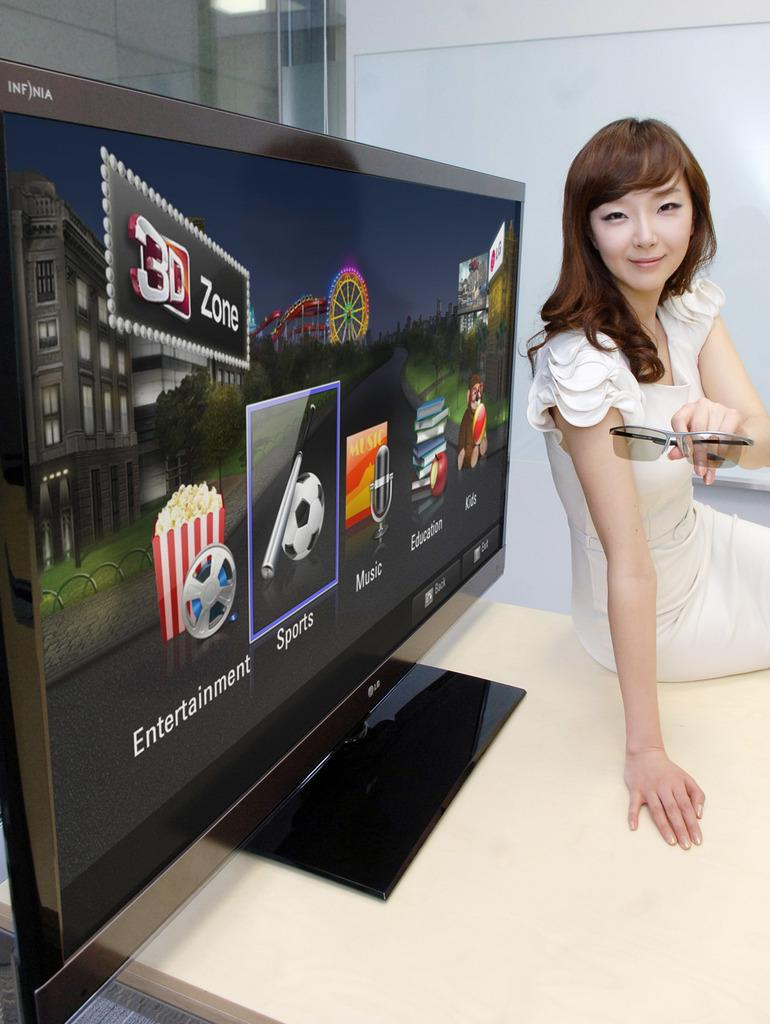<image>
Give a short and clear explanation of the subsequent image. a woman in front of a monitor with icons for Entertainment and Sports 